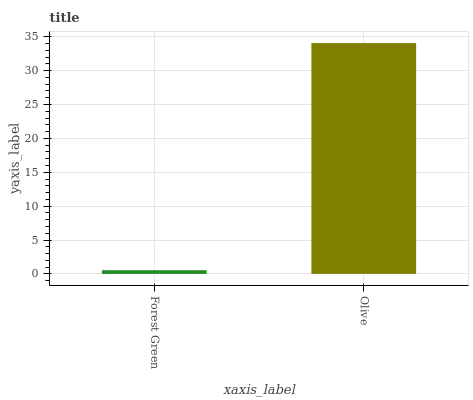Is Olive the minimum?
Answer yes or no. No. Is Olive greater than Forest Green?
Answer yes or no. Yes. Is Forest Green less than Olive?
Answer yes or no. Yes. Is Forest Green greater than Olive?
Answer yes or no. No. Is Olive less than Forest Green?
Answer yes or no. No. Is Olive the high median?
Answer yes or no. Yes. Is Forest Green the low median?
Answer yes or no. Yes. Is Forest Green the high median?
Answer yes or no. No. Is Olive the low median?
Answer yes or no. No. 